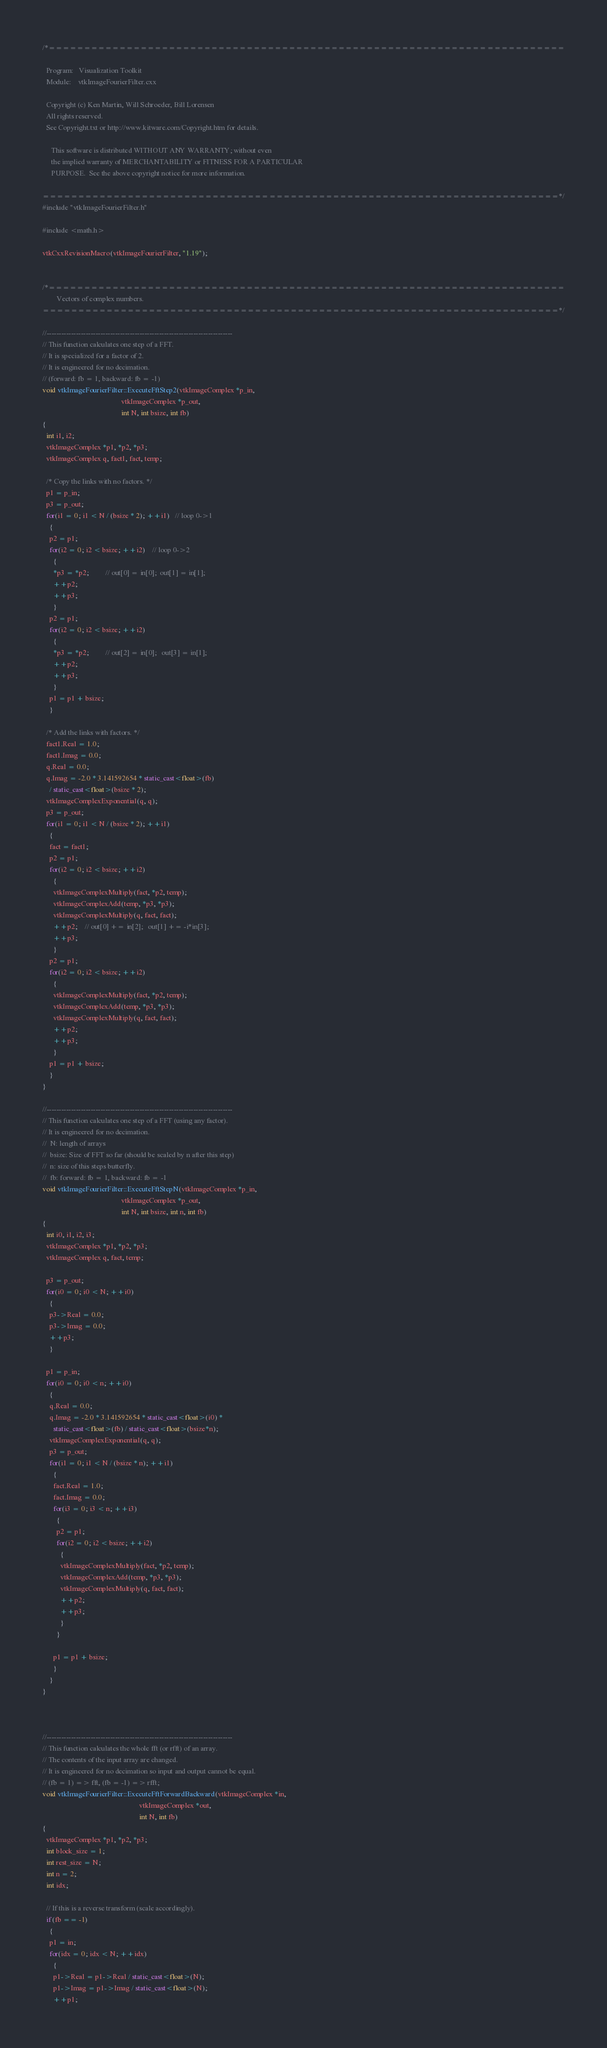<code> <loc_0><loc_0><loc_500><loc_500><_C++_>/*=========================================================================

  Program:   Visualization Toolkit
  Module:    vtkImageFourierFilter.cxx

  Copyright (c) Ken Martin, Will Schroeder, Bill Lorensen
  All rights reserved.
  See Copyright.txt or http://www.kitware.com/Copyright.htm for details.

     This software is distributed WITHOUT ANY WARRANTY; without even
     the implied warranty of MERCHANTABILITY or FITNESS FOR A PARTICULAR
     PURPOSE.  See the above copyright notice for more information.

=========================================================================*/
#include "vtkImageFourierFilter.h"

#include <math.h>

vtkCxxRevisionMacro(vtkImageFourierFilter, "1.19");


/*=========================================================================
        Vectors of complex numbers.
=========================================================================*/

//----------------------------------------------------------------------------
// This function calculates one step of a FFT.
// It is specialized for a factor of 2. 
// It is engineered for no decimation.
// (forward: fb = 1, backward: fb = -1)
void vtkImageFourierFilter::ExecuteFftStep2(vtkImageComplex *p_in, 
                                            vtkImageComplex *p_out, 
                                            int N, int bsize, int fb)
{
  int i1, i2;
  vtkImageComplex *p1, *p2, *p3;
  vtkImageComplex q, fact1, fact, temp;
  
  /* Copy the links with no factors. */
  p1 = p_in;
  p3 = p_out;
  for(i1 = 0; i1 < N / (bsize * 2); ++i1)   // loop 0->1
    {
    p2 = p1;
    for(i2 = 0; i2 < bsize; ++i2)    // loop 0->2
      {
      *p3 = *p2;         // out[0] = in[0];  out[1] = in[1];
      ++p2;
      ++p3;
      }
    p2 = p1;
    for(i2 = 0; i2 < bsize; ++i2)
      {
      *p3 = *p2;         // out[2] = in[0];   out[3] = in[1];
      ++p2;
      ++p3;
      }
    p1 = p1 + bsize;
    }
  
  /* Add the links with factors. */
  fact1.Real = 1.0;
  fact1.Imag = 0.0;
  q.Real = 0.0;
  q.Imag = -2.0 * 3.141592654 * static_cast<float>(fb)
    / static_cast<float>(bsize * 2);
  vtkImageComplexExponential(q, q);
  p3 = p_out;
  for(i1 = 0; i1 < N / (bsize * 2); ++i1)
    {
    fact = fact1;
    p2 = p1;
    for(i2 = 0; i2 < bsize; ++i2)
      {
      vtkImageComplexMultiply(fact, *p2, temp);
      vtkImageComplexAdd(temp, *p3, *p3);
      vtkImageComplexMultiply(q, fact, fact);
      ++p2;    // out[0] += in[2];   out[1] += -i*in[3];
      ++p3;
      }
    p2 = p1;
    for(i2 = 0; i2 < bsize; ++i2)
      {
      vtkImageComplexMultiply(fact, *p2, temp);
      vtkImageComplexAdd(temp, *p3, *p3);
      vtkImageComplexMultiply(q, fact, fact);
      ++p2;
      ++p3;
      }
    p1 = p1 + bsize;
    }
}

//----------------------------------------------------------------------------
// This function calculates one step of a FFT (using any factor).
// It is engineered for no decimation.
//  N: length of arrays 
//  bsize: Size of FFT so far (should be scaled by n after this step)
//  n: size of this steps butterfly.
//  fb: forward: fb = 1, backward: fb = -1 
void vtkImageFourierFilter::ExecuteFftStepN(vtkImageComplex *p_in, 
                                            vtkImageComplex *p_out,
                                            int N, int bsize, int n, int fb)
{
  int i0, i1, i2, i3;
  vtkImageComplex *p1, *p2, *p3;
  vtkImageComplex q, fact, temp;

  p3 = p_out; 
  for(i0 = 0; i0 < N; ++i0)
    {
    p3->Real = 0.0;
    p3->Imag = 0.0;
    ++p3;
    }
  
  p1 = p_in;
  for(i0 = 0; i0 < n; ++i0)
    {
    q.Real = 0.0;
    q.Imag = -2.0 * 3.141592654 * static_cast<float>(i0) *
      static_cast<float>(fb) / static_cast<float>(bsize*n);
    vtkImageComplexExponential(q, q);
    p3 = p_out;
    for(i1 = 0; i1 < N / (bsize * n); ++i1)
      {
      fact.Real = 1.0;
      fact.Imag = 0.0;
      for(i3 = 0; i3 < n; ++i3)
        {
        p2 = p1;
        for(i2 = 0; i2 < bsize; ++i2)
          {
          vtkImageComplexMultiply(fact, *p2, temp);
          vtkImageComplexAdd(temp, *p3, *p3);
          vtkImageComplexMultiply(q, fact, fact);
          ++p2;
          ++p3;
          }
        }
      
      p1 = p1 + bsize;
      }
    }
}



//----------------------------------------------------------------------------
// This function calculates the whole fft (or rfft) of an array.
// The contents of the input array are changed.
// It is engineered for no decimation so input and output cannot be equal.
// (fb = 1) => fft, (fb = -1) => rfft;
void vtkImageFourierFilter::ExecuteFftForwardBackward(vtkImageComplex *in, 
                                                      vtkImageComplex *out, 
                                                      int N, int fb)
{
  vtkImageComplex *p1, *p2, *p3;
  int block_size = 1;
  int rest_size = N;
  int n = 2;
  int idx;

  // If this is a reverse transform (scale accordingly).
  if(fb == -1)
    {  
    p1 = in;
    for(idx = 0; idx < N; ++idx)
      {
      p1->Real = p1->Real / static_cast<float>(N);
      p1->Imag = p1->Imag / static_cast<float>(N);
      ++p1;</code> 